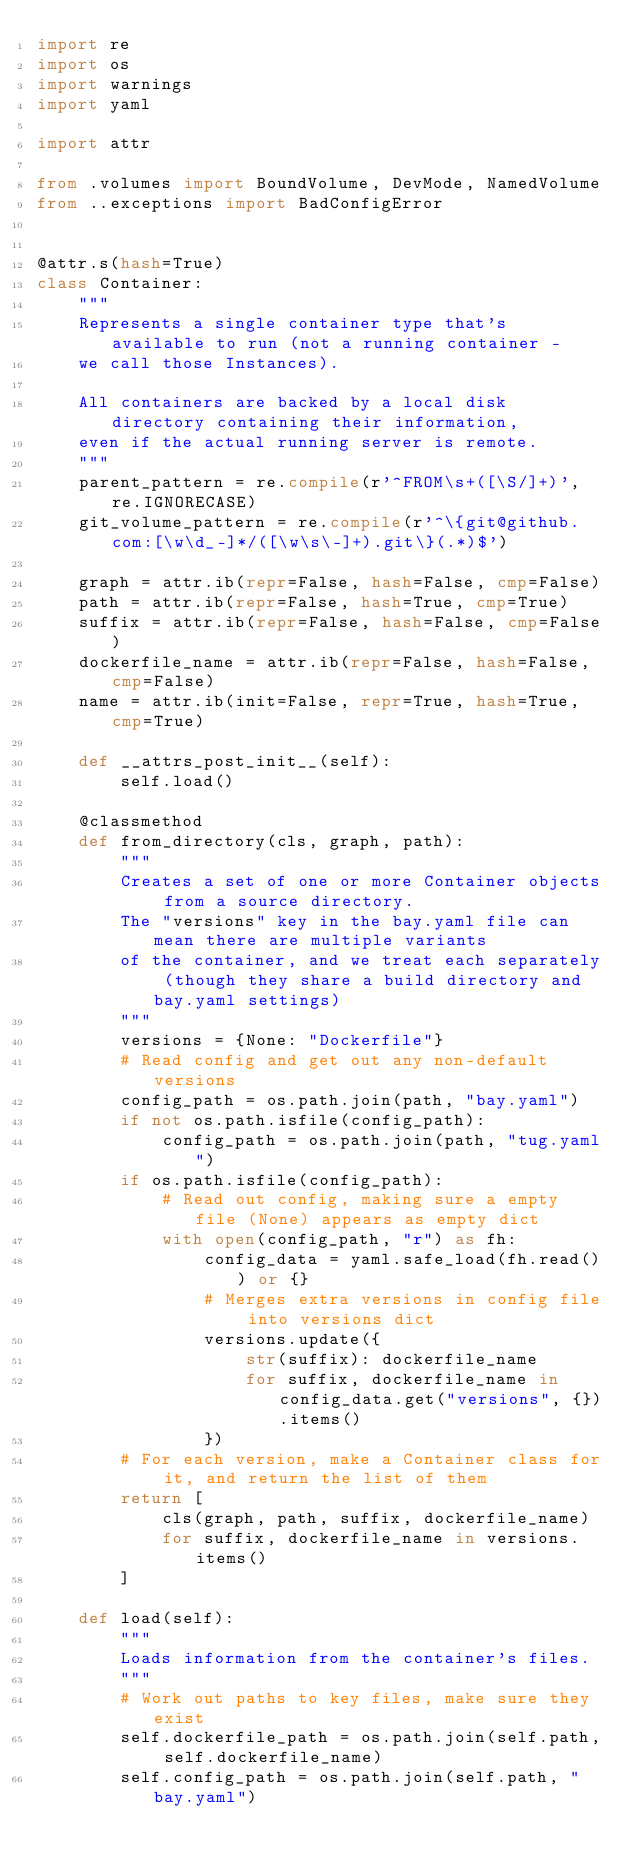<code> <loc_0><loc_0><loc_500><loc_500><_Python_>import re
import os
import warnings
import yaml

import attr

from .volumes import BoundVolume, DevMode, NamedVolume
from ..exceptions import BadConfigError


@attr.s(hash=True)
class Container:
    """
    Represents a single container type that's available to run (not a running container -
    we call those Instances).

    All containers are backed by a local disk directory containing their information,
    even if the actual running server is remote.
    """
    parent_pattern = re.compile(r'^FROM\s+([\S/]+)', re.IGNORECASE)
    git_volume_pattern = re.compile(r'^\{git@github.com:[\w\d_-]*/([\w\s\-]+).git\}(.*)$')

    graph = attr.ib(repr=False, hash=False, cmp=False)
    path = attr.ib(repr=False, hash=True, cmp=True)
    suffix = attr.ib(repr=False, hash=False, cmp=False)
    dockerfile_name = attr.ib(repr=False, hash=False, cmp=False)
    name = attr.ib(init=False, repr=True, hash=True, cmp=True)

    def __attrs_post_init__(self):
        self.load()

    @classmethod
    def from_directory(cls, graph, path):
        """
        Creates a set of one or more Container objects from a source directory.
        The "versions" key in the bay.yaml file can mean there are multiple variants
        of the container, and we treat each separately (though they share a build directory and bay.yaml settings)
        """
        versions = {None: "Dockerfile"}
        # Read config and get out any non-default versions
        config_path = os.path.join(path, "bay.yaml")
        if not os.path.isfile(config_path):
            config_path = os.path.join(path, "tug.yaml")
        if os.path.isfile(config_path):
            # Read out config, making sure a empty file (None) appears as empty dict
            with open(config_path, "r") as fh:
                config_data = yaml.safe_load(fh.read()) or {}
                # Merges extra versions in config file into versions dict
                versions.update({
                    str(suffix): dockerfile_name
                    for suffix, dockerfile_name in config_data.get("versions", {}).items()
                })
        # For each version, make a Container class for it, and return the list of them
        return [
            cls(graph, path, suffix, dockerfile_name)
            for suffix, dockerfile_name in versions.items()
        ]

    def load(self):
        """
        Loads information from the container's files.
        """
        # Work out paths to key files, make sure they exist
        self.dockerfile_path = os.path.join(self.path, self.dockerfile_name)
        self.config_path = os.path.join(self.path, "bay.yaml")</code> 